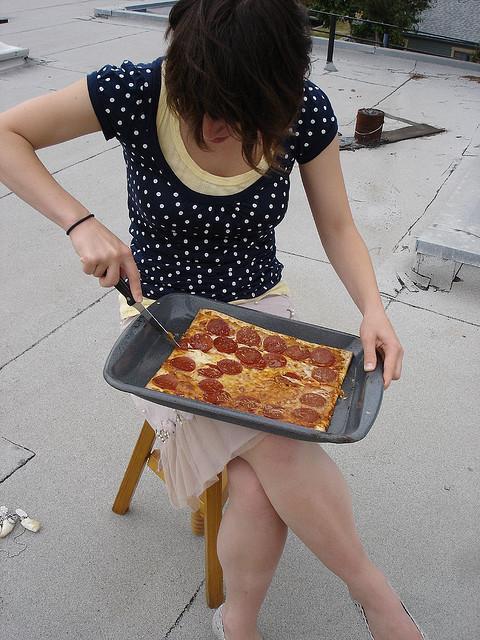What is different about this pizza than most pizzas?
Answer the question by selecting the correct answer among the 4 following choices.
Options: Square shape, no cheese, all mushrooms, missing toppings. Square shape. 